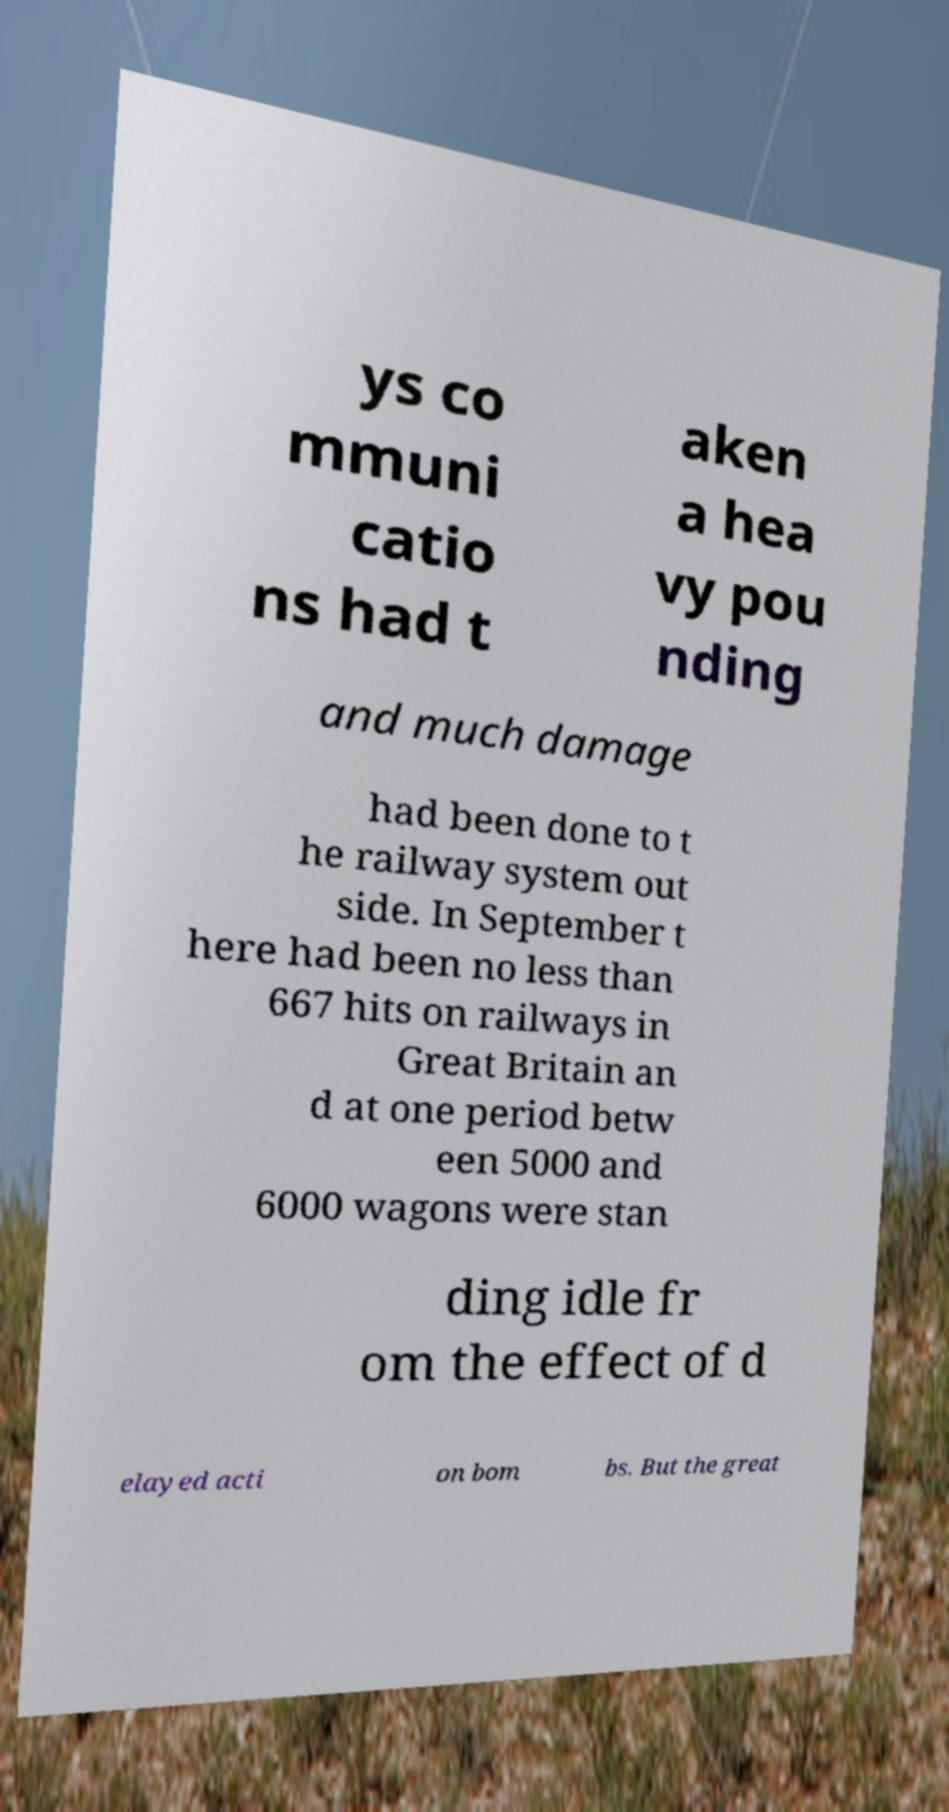Can you read and provide the text displayed in the image?This photo seems to have some interesting text. Can you extract and type it out for me? ys co mmuni catio ns had t aken a hea vy pou nding and much damage had been done to t he railway system out side. In September t here had been no less than 667 hits on railways in Great Britain an d at one period betw een 5000 and 6000 wagons were stan ding idle fr om the effect of d elayed acti on bom bs. But the great 